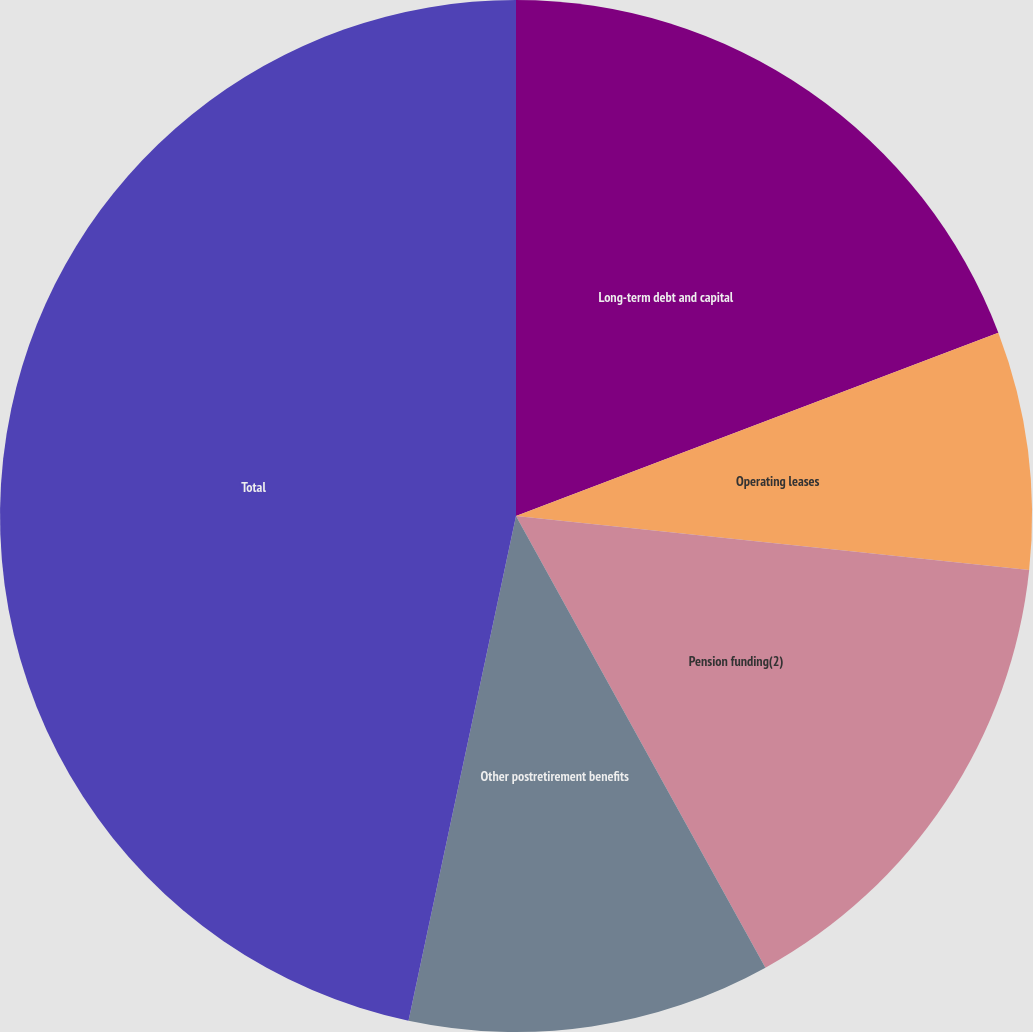Convert chart to OTSL. <chart><loc_0><loc_0><loc_500><loc_500><pie_chart><fcel>Long-term debt and capital<fcel>Operating leases<fcel>Pension funding(2)<fcel>Other postretirement benefits<fcel>Total<nl><fcel>19.22%<fcel>7.45%<fcel>15.3%<fcel>11.37%<fcel>46.66%<nl></chart> 